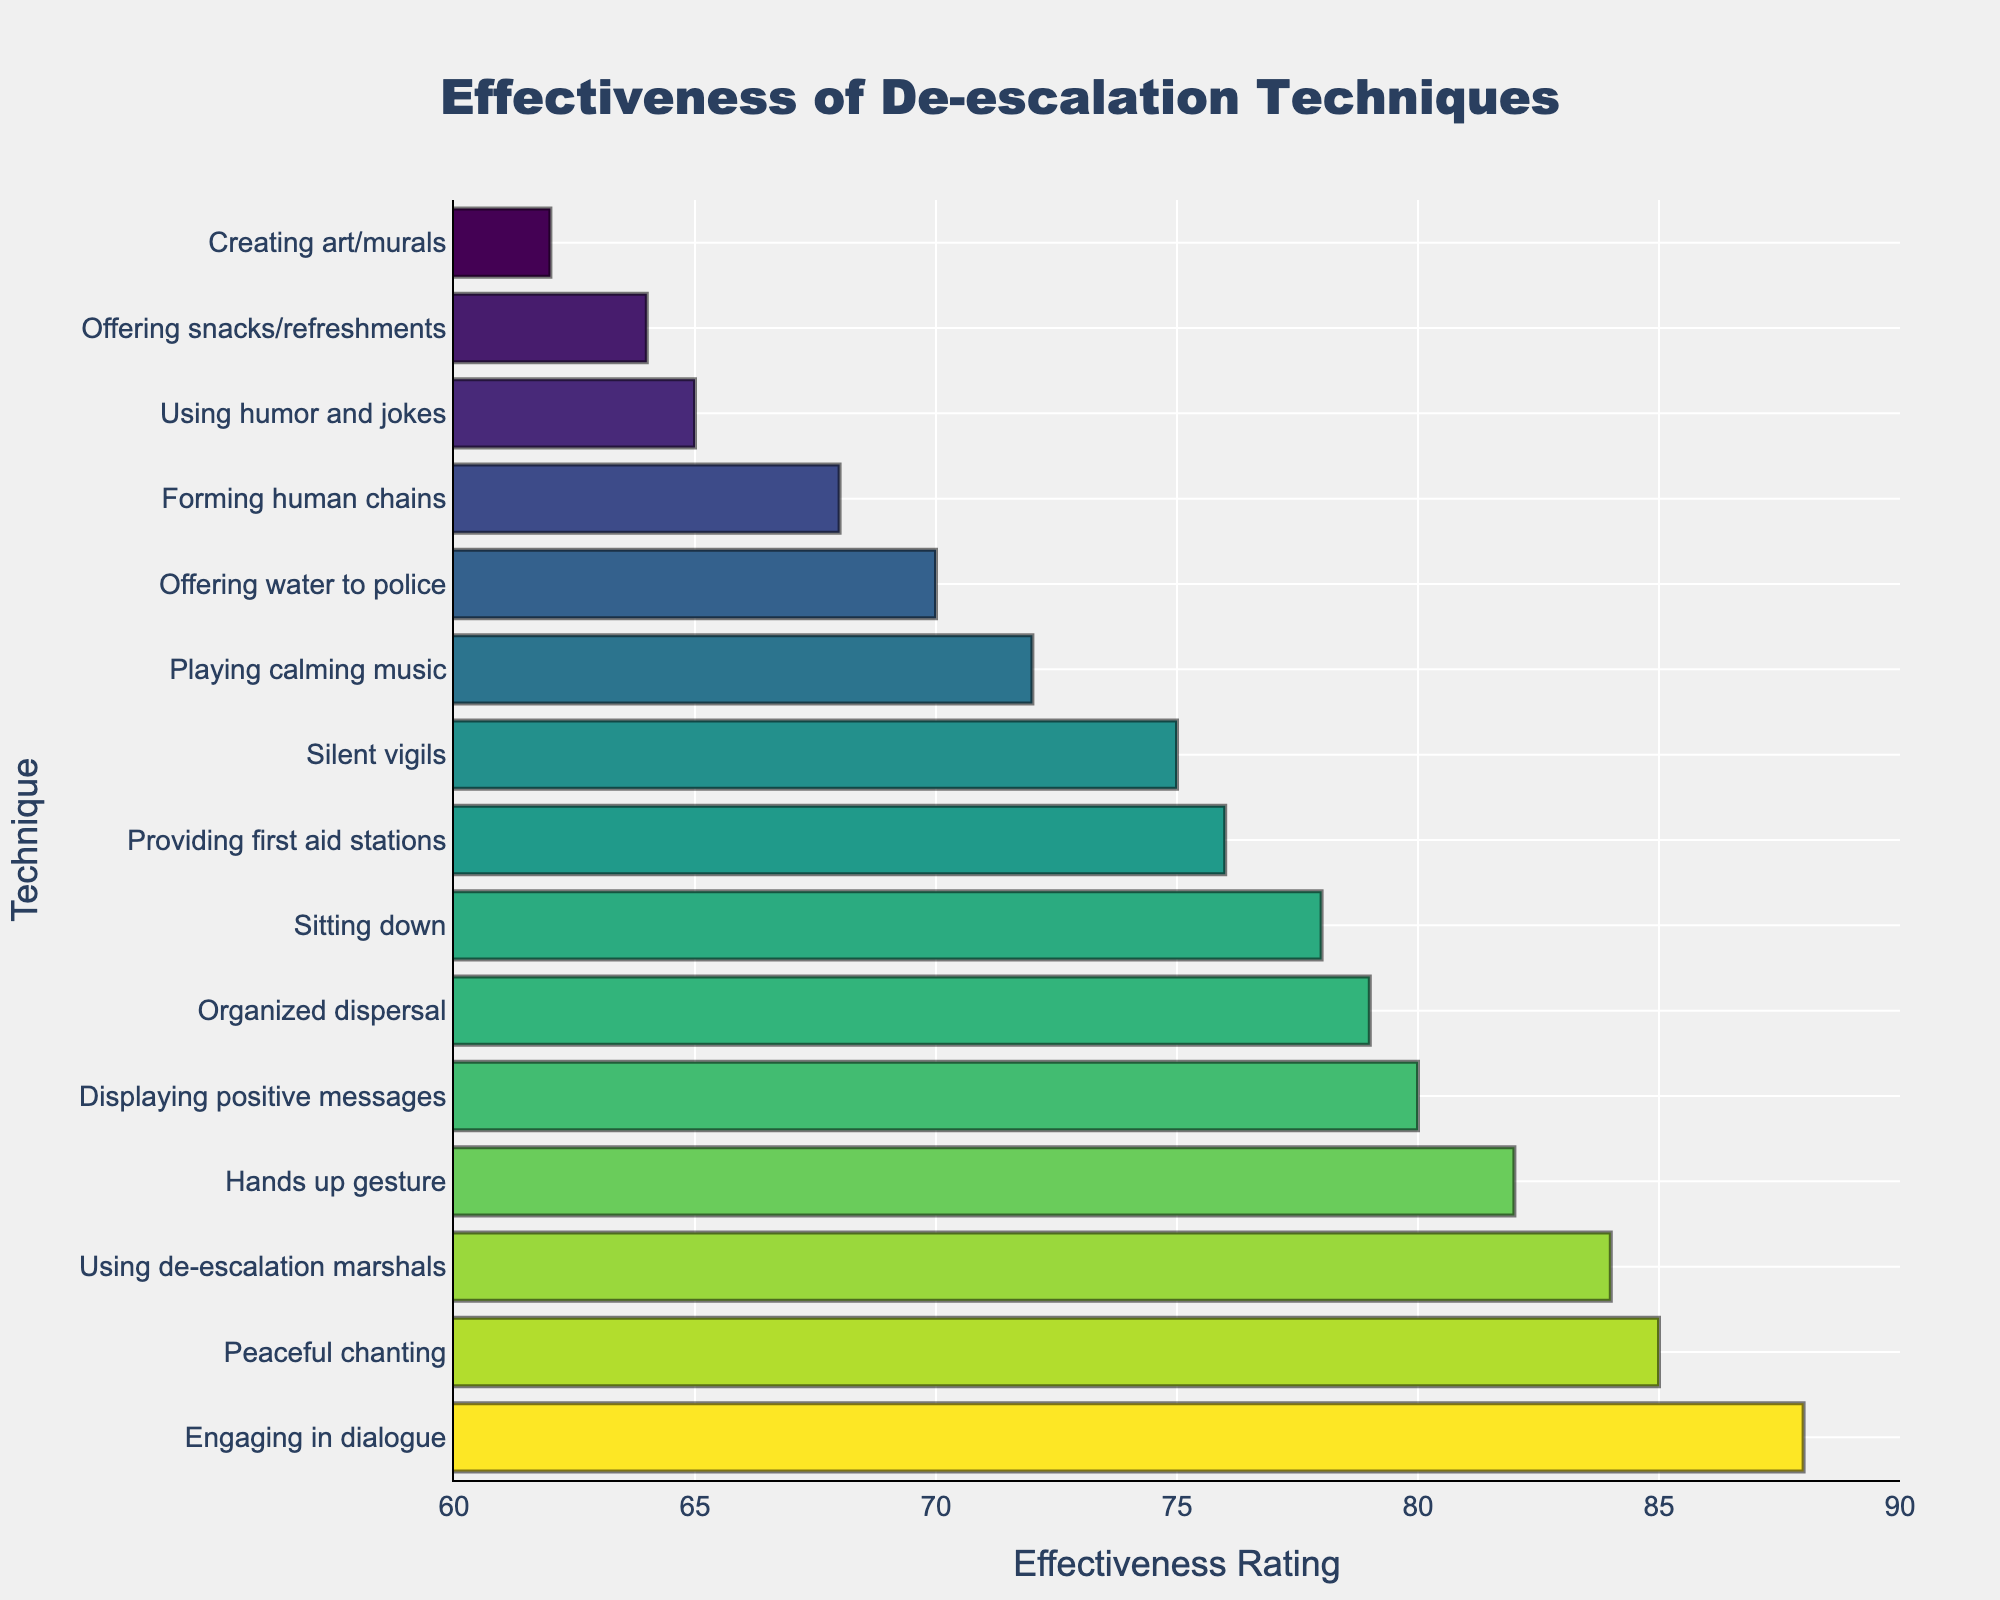What's the most effective de-escalation technique according to the ratings? The bar chart shows the effectiveness ratings of different de-escalation techniques. The highest bar represents the most effective technique.
Answer: Engaging in dialogue Which technique has a higher effectiveness rating: 'Silent vigils' or 'Playing calming music'? To answer this comparison question, look at the ratings for the two techniques. 'Silent vigils' has a rating of 75, while 'Playing calming music' has a rating of 72.
Answer: Silent vigils What's the average effectiveness rating of all the techniques? First, sum up all the effectiveness ratings: 85 + 78 + 82 + 70 + 65 + 72 + 68 + 75 + 80 + 88 + 62 + 79 + 84 + 76 + 64 = 1128. Then, divide by the total number of techniques (15). 1128 / 15 = 75.2
Answer: 75.2 Which technique is more effective than 'Forming human chains' but less effective than 'Using de-escalation marshals'? 'Forming human chains' has a rating of 68, and 'Using de-escalation marshals' has a rating of 84. The technique that fits in-between is 'Silent vigils' with a rating of 75.
Answer: Silent vigils What's the total effectiveness rating for 'Offering water to police' and 'Using humor and jokes'? Add the effectiveness ratings of the two techniques: 70 + 65 = 135
Answer: 135 What's the margin between the highest and lowest rated techniques? Subtract the lowest effectiveness rating from the highest. The highest is 88 (Engaging in dialogue), and the lowest is 62 (Creating art/murals). 88 - 62 = 26
Answer: 26 Among the techniques with an effectiveness rating higher than 80, which one has the closest rating to 80? The techniques with ratings higher than 80 are: 'Peaceful chanting' (85), 'Hands up gesture' (82), 'Displaying positive messages' (80), 'Engaging in dialogue' (88), and 'Using de-escalation marshals' (84). 'Hands up gesture' with a rating of 82 is the closest to 80.
Answer: Hands up gesture How many techniques have an effectiveness rating of 75 or higher? Count the techniques with a rating of 75 or higher: 'Peaceful chanting', 'Sitting down', 'Hands up gesture', 'Displaying positive messages', 'Engaging in dialogue', 'Silent vigils', 'Organized dispersal', 'Using de-escalation marshals', 'Providing first aid stations' (85, 78, 82, 80, 88, 75, 79, 84, 76). There are 9 such techniques.
Answer: 9 